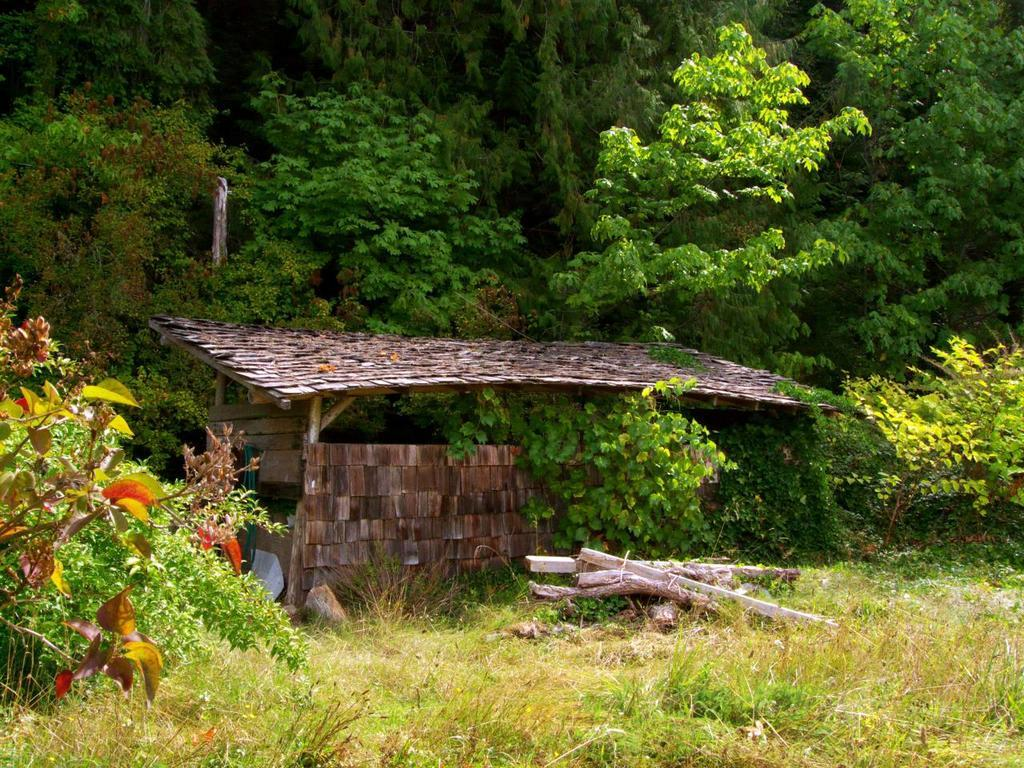What is the main structure in the center of the image? There is a shed in the center of the image. What objects can be seen at the bottom of the image? Logs and grass are visible at the bottom of the image. What type of vegetation is in the background of the image? There are trees in the background of the image. What type of lead is being used by the band in the image? There is no band or lead present in the image; it features a shed, logs, grass, and trees. 